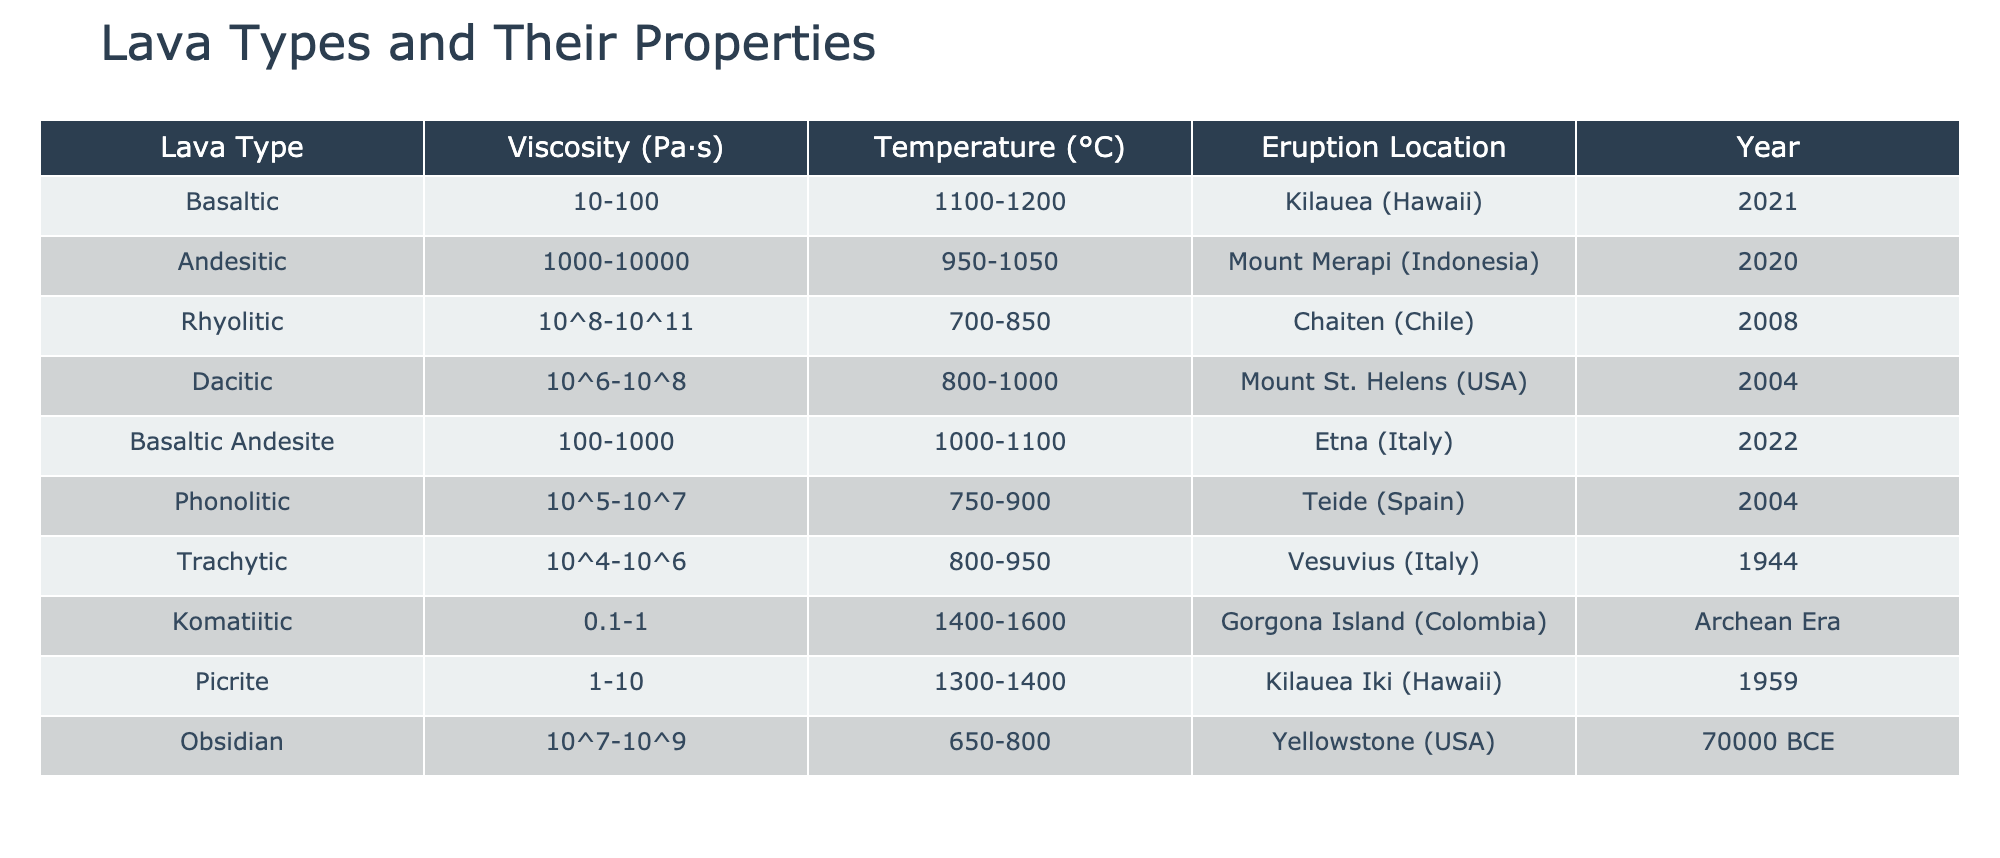What is the viscosity range for Rhyolitic lava? The viscosity range for Rhyolitic lava is listed in the table as 10^8-10^11 Pa·s.
Answer: 10^8-10^11 Pa·s Which lava type has the highest recorded temperature? By examining the temperature column, Komatiitic lava has the highest temperature range, which is 1400-1600 °C.
Answer: 1400-1600 °C Is Andesitic lava observed at a higher temperature than Dokitic lava? From the table, Andesitic lava has a temperature range of 950-1050 °C, while Dacitic lava has a range of 800-1000 °C, indicating that Andesitic lava is indeed observed at a higher temperature.
Answer: Yes What is the average viscosity of Basaltic lava types? The Basaltic lava types listed are Basaltic (10-100 Pa·s) and Basaltic Andesite (100-1000 Pa·s). To find the average viscosity, we take the midpoints: (55 + 550) / 2 = 302.5 Pa·s.
Answer: 302.5 Pa·s How many lava types have a viscosity greater than 10^6 Pa·s? The viscosity values greater than 10^6 Pa·s are found in the following lava types: Andesitic, Rhyolitic, Dacitic, Phonolitic, and Trachytic. Counting these, we find there are 5 lava types in total.
Answer: 5 What is the temperature range for lava types that have a viscosity of 10^5 Pa·s and above? Based on the table, the lava types with a viscosity of 10^5 Pa·s and above include Rhyolitic (700-850 °C), Dacitic (800-1000 °C), Phonolitic (750-900 °C), Trachytic (800-950 °C), and Obsidian (650-800 °C). The minimum temperature is 650 °C, and the maximum is 1000 °C, resulting in a range of 650-1000 °C.
Answer: 650-1000 °C Is there any lava type that erupts at a temperature below 700 °C? By checking the temperature ranges for each lava type, we can see that none of the values fall below 700 °C; hence, the answer is that there are no lava types that erupt below this temperature.
Answer: No What is the difference in viscosity between Komatiitic and Rhyolitic lava? Komatiitic lava has a viscosity range of 0.1-1 Pa·s, while Rhyolitic ranges from 10^8-10^11 Pa·s. The difference is large, so we can conclude that Rhyolitic lava is much more viscous compared to Komatiitic lava.
Answer: Rhyolitic is much more viscous 